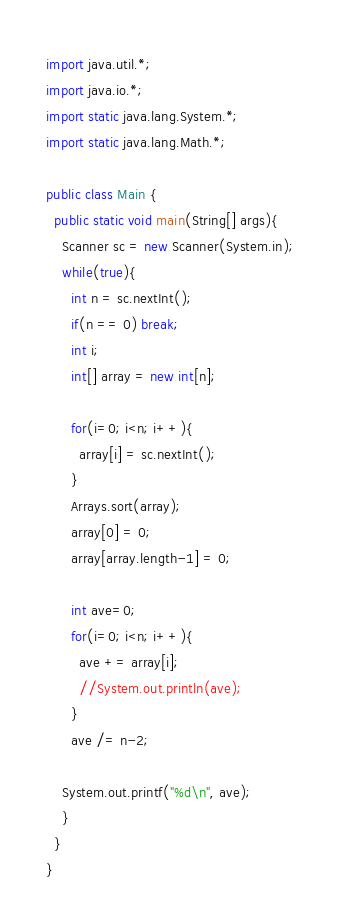Convert code to text. <code><loc_0><loc_0><loc_500><loc_500><_Java_>import java.util.*;
import java.io.*;
import static java.lang.System.*;
import static java.lang.Math.*;

public class Main {
  public static void main(String[] args){
    Scanner sc = new Scanner(System.in);
    while(true){
      int n = sc.nextInt();
      if(n == 0) break;
      int i;
      int[] array = new int[n];

      for(i=0; i<n; i++){
        array[i] = sc.nextInt();
      }
      Arrays.sort(array);
      array[0] = 0;
      array[array.length-1] = 0;

      int ave=0;
      for(i=0; i<n; i++){
        ave += array[i];
        //System.out.println(ave);
      }
      ave /= n-2;

    System.out.printf("%d\n", ave);
    }
  }
}
</code> 